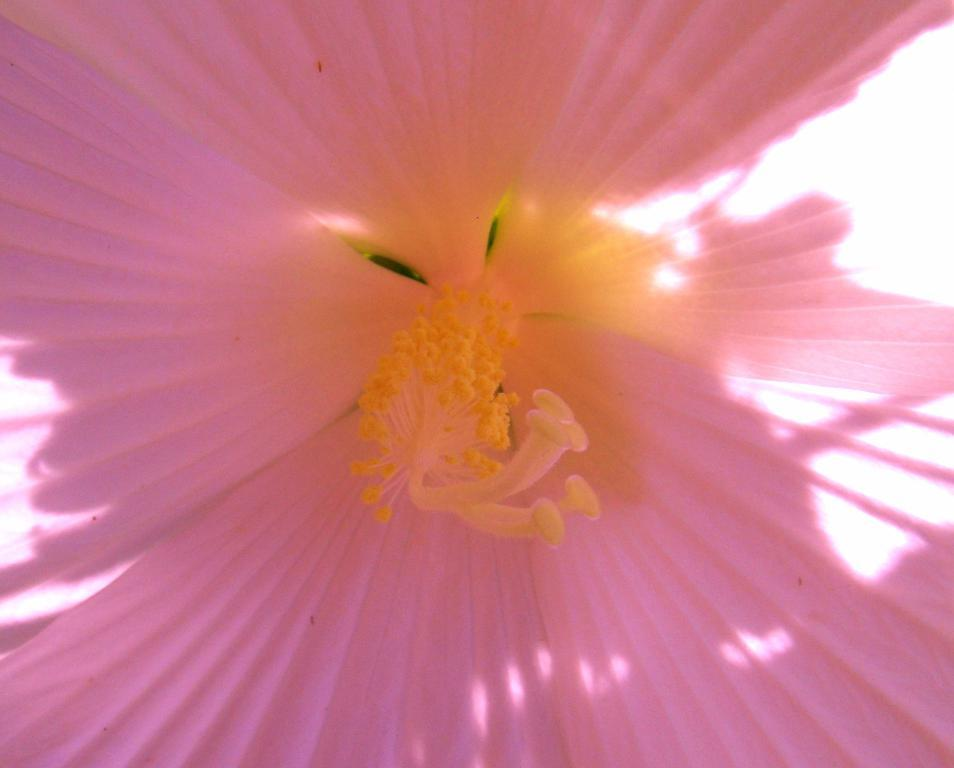What is the main subject of the zoomed image? The main subject of the zoomed image is a flower. What type of star can be seen in the background of the image? There is no star present in the image, as it is a zoomed image of a flower. 